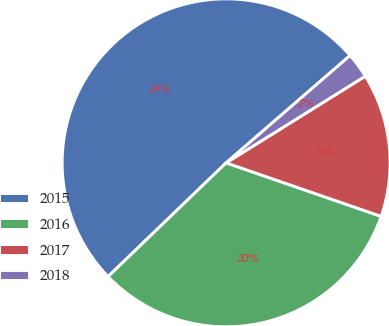Convert chart to OTSL. <chart><loc_0><loc_0><loc_500><loc_500><pie_chart><fcel>2015<fcel>2016<fcel>2017<fcel>2018<nl><fcel>50.84%<fcel>32.5%<fcel>14.16%<fcel>2.49%<nl></chart> 